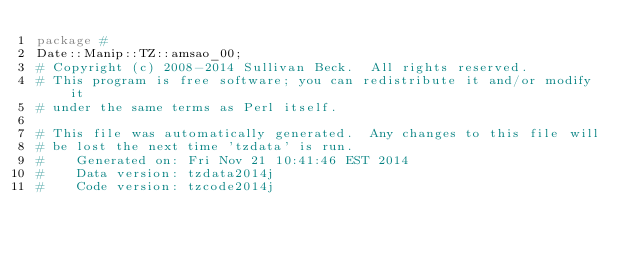Convert code to text. <code><loc_0><loc_0><loc_500><loc_500><_Perl_>package #
Date::Manip::TZ::amsao_00;
# Copyright (c) 2008-2014 Sullivan Beck.  All rights reserved.
# This program is free software; you can redistribute it and/or modify it
# under the same terms as Perl itself.

# This file was automatically generated.  Any changes to this file will
# be lost the next time 'tzdata' is run.
#    Generated on: Fri Nov 21 10:41:46 EST 2014
#    Data version: tzdata2014j
#    Code version: tzcode2014j
</code> 